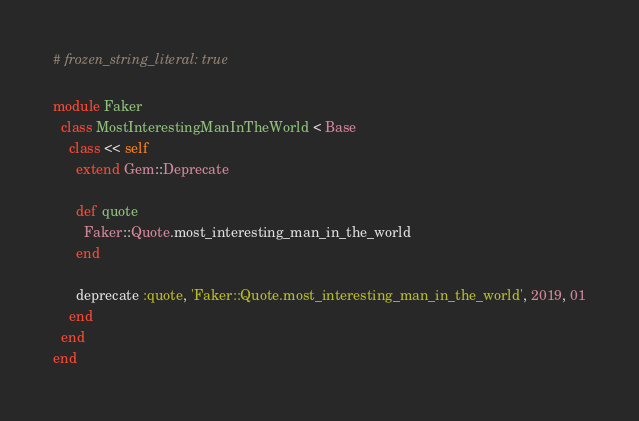Convert code to text. <code><loc_0><loc_0><loc_500><loc_500><_Ruby_># frozen_string_literal: true

module Faker
  class MostInterestingManInTheWorld < Base
    class << self
      extend Gem::Deprecate

      def quote
        Faker::Quote.most_interesting_man_in_the_world
      end

      deprecate :quote, 'Faker::Quote.most_interesting_man_in_the_world', 2019, 01
    end
  end
end
</code> 